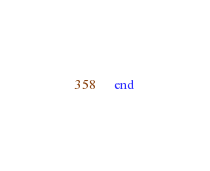<code> <loc_0><loc_0><loc_500><loc_500><_Crystal_>end
</code> 